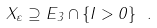<formula> <loc_0><loc_0><loc_500><loc_500>X _ { \varepsilon } \supseteq E _ { 3 } \cap \{ I > 0 \} \ .</formula> 